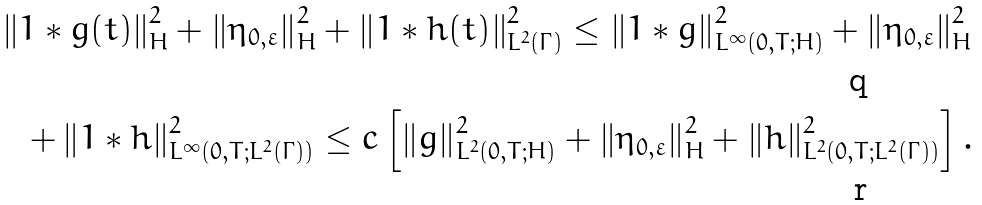<formula> <loc_0><loc_0><loc_500><loc_500>\left \| 1 \ast g ( t ) \right \| ^ { 2 } _ { H } + \left \| \eta _ { 0 , \varepsilon } \right \| ^ { 2 } _ { H } + \left \| 1 \ast h ( t ) \right \| ^ { 2 } _ { L ^ { 2 } ( \Gamma ) } \leq \left \| 1 \ast g \right \| ^ { 2 } _ { L ^ { \infty } ( 0 , T ; H ) } + \left \| \eta _ { 0 , \varepsilon } \right \| ^ { 2 } _ { H } \\ + \left \| 1 \ast h \right \| ^ { 2 } _ { L ^ { \infty } ( 0 , T ; L ^ { 2 } ( \Gamma ) ) } \leq c \left [ \left \| g \right \| ^ { 2 } _ { L ^ { 2 } ( 0 , T ; H ) } + \left \| \eta _ { 0 , \varepsilon } \right \| ^ { 2 } _ { H } + \left \| h \right \| ^ { 2 } _ { L ^ { 2 } ( 0 , T ; L ^ { 2 } ( \Gamma ) ) } \right ] .</formula> 